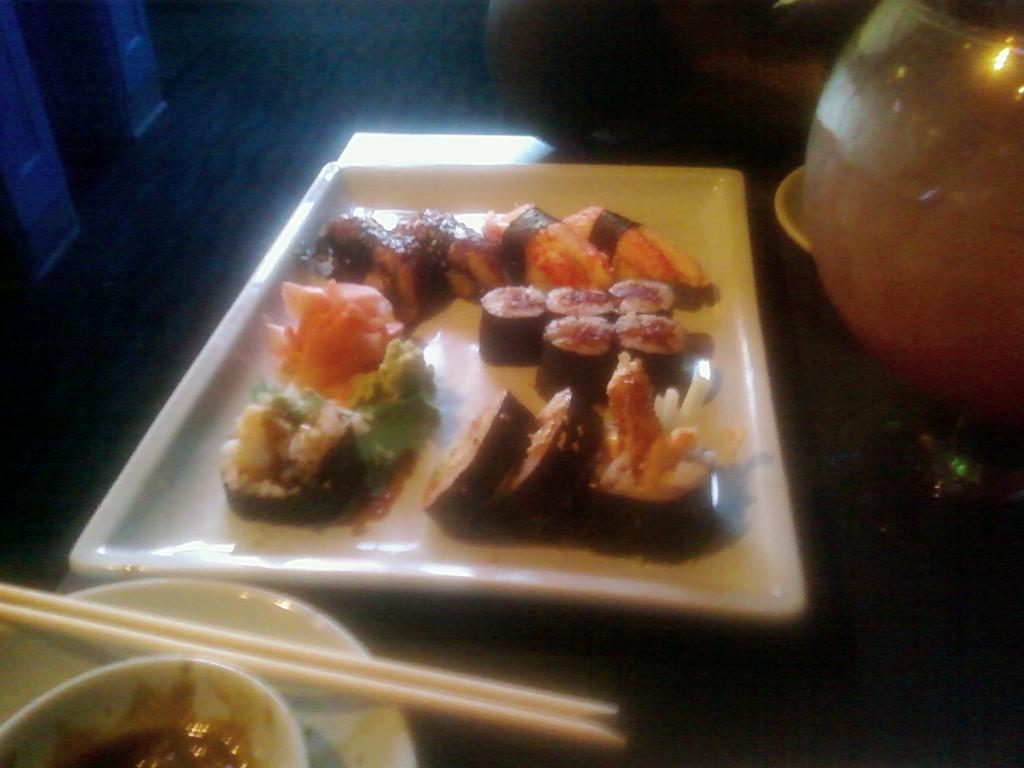What is on the plate that is visible in the image? There is a plate with food in the image. What other objects can be seen in the image? There is a bowl, chopping sticks, and a pot visible in the image. What might be used for eating the food on the plate? Chopping sticks are visible in the image, which might be used for eating the food. Where are all these objects located in the image? All these objects are on a surface in the image. What type of nerve is present in the image? There is no nerve present in the image; it features a plate with food, a bowl, chopping sticks, and a pot on a surface. How many loaves of bread are visible in the image? There is no loaf of bread present in the image. 